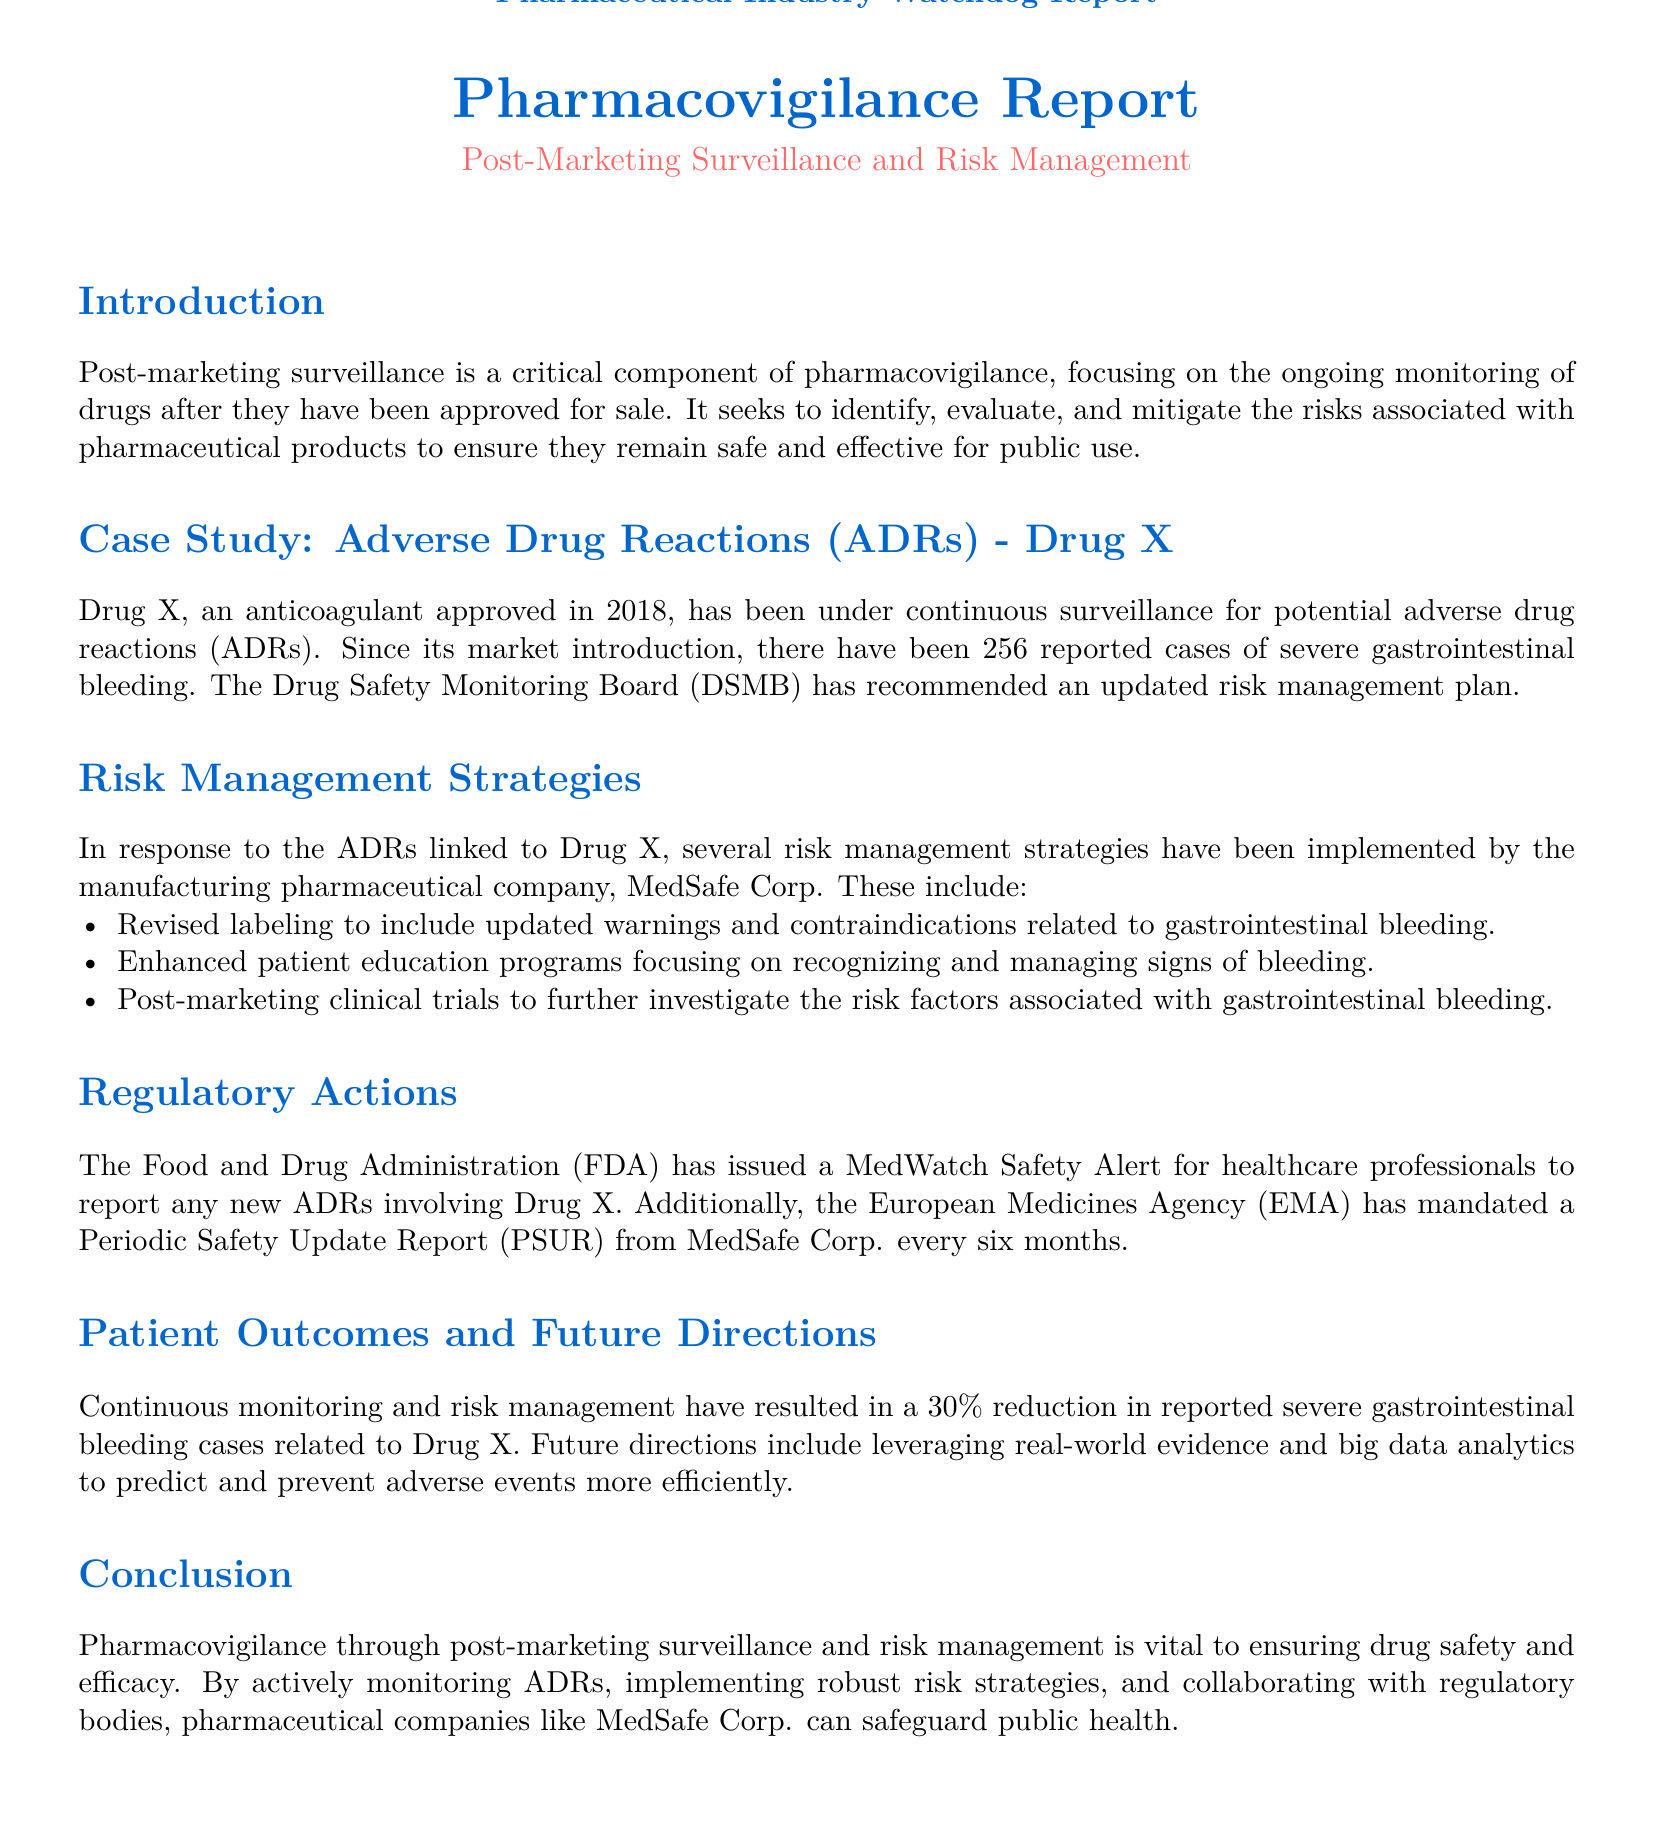What is the main focus of post-marketing surveillance? The main focus is the ongoing monitoring of drugs after they have been approved for sale to ensure they remain safe and effective.
Answer: ongoing monitoring How many severe gastrointestinal bleeding cases were reported for Drug X? The document states there have been 256 reported cases of severe gastrointestinal bleeding since the market introduction of Drug X.
Answer: 256 What company manufactures Drug X? The manufacturing pharmaceutical company mentioned in the document is MedSafe Corp.
Answer: MedSafe Corp What specific type of alert did the FDA issue for Drug X? The alert issued by the FDA is called a MedWatch Safety Alert.
Answer: MedWatch Safety Alert What percentage reduction in reported cases has been achieved through risk management? The document indicates there has been a 30 percent reduction in reported severe gastrointestinal bleeding cases related to Drug X.
Answer: 30% What are the two regulatory bodies mentioned in relation to Drug X? The two regulatory bodies mentioned are the Food and Drug Administration (FDA) and the European Medicines Agency (EMA).
Answer: FDA and EMA What type of trials are being conducted to investigate ADRs for Drug X? The company is conducting post-marketing clinical trials to further investigate risk factors associated with gastrointestinal bleeding.
Answer: post-marketing clinical trials What is one of the risk management strategies employed by MedSafe Corp.? One of the strategies is revised labeling to include updated warnings and contraindications related to gastrointestinal bleeding.
Answer: revised labeling What future direction is suggested for preventing adverse events? The document states that leveraging real-world evidence and big data analytics is suggested for predicting and preventing adverse events more efficiently.
Answer: real-world evidence and big data analytics 